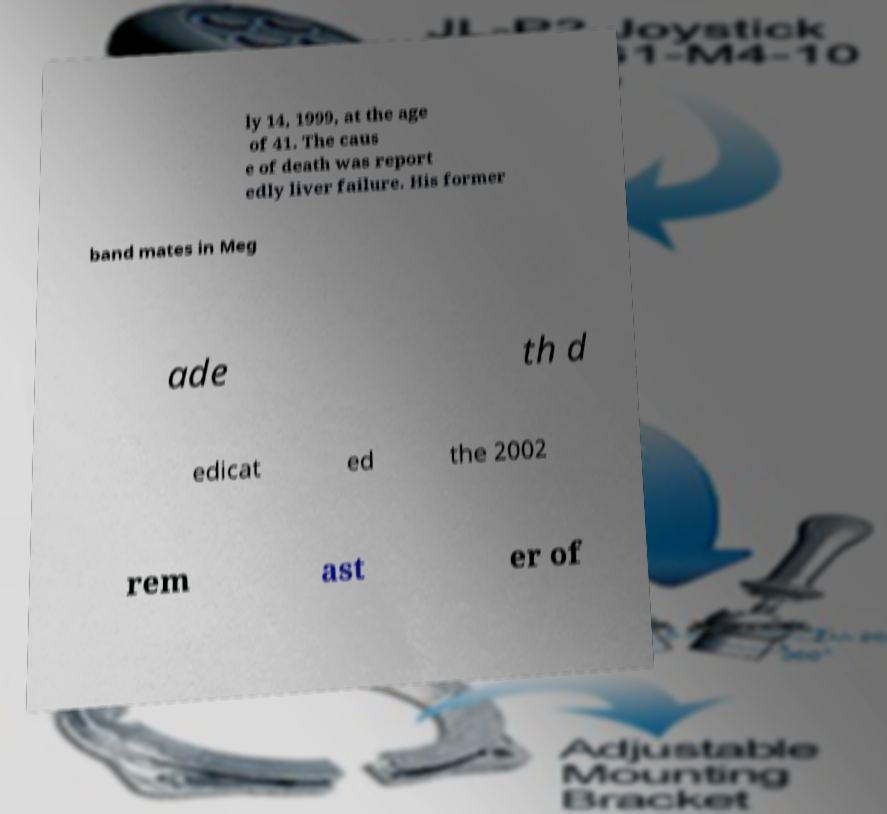Could you assist in decoding the text presented in this image and type it out clearly? ly 14, 1999, at the age of 41. The caus e of death was report edly liver failure. His former band mates in Meg ade th d edicat ed the 2002 rem ast er of 